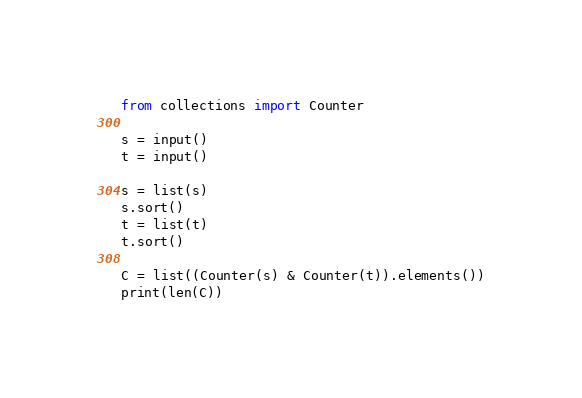Convert code to text. <code><loc_0><loc_0><loc_500><loc_500><_Python_>from collections import Counter

s = input()
t = input()

s = list(s)
s.sort()
t = list(t)
t.sort()

C = list((Counter(s) & Counter(t)).elements())
print(len(C))</code> 